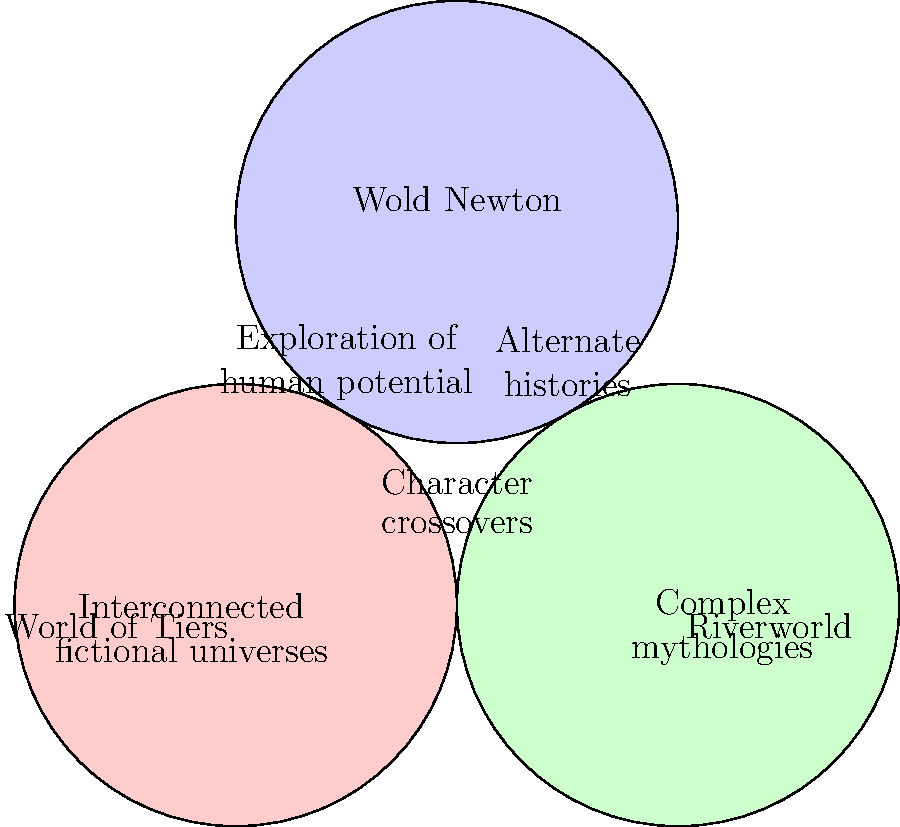Analyze the Venn diagram illustrating common themes across Philip José Farmer's major series (World of Tiers, Riverworld, and Wold Newton). Which theme is shared by all three series, representing Farmer's overarching interest throughout his literary career? To answer this question, let's examine the Venn diagram step-by-step:

1. The diagram shows three overlapping circles, each representing one of Farmer's major series:
   - World of Tiers
   - Riverworld
   - Wold Newton

2. Each circle contains themes specific to that series, while overlapping areas represent shared themes.

3. The themes specific to each series are:
   - World of Tiers: "Exploration of human potential"
   - Riverworld: "Complex mythologies"
   - Wold Newton: "Alternate histories"

4. Themes shared by two series:
   - World of Tiers and Riverworld: "Interconnected fictional universes"
   - Riverworld and Wold Newton: "Character crossovers"

5. The central area where all three circles overlap represents a theme common to all three series.

6. The theme in this central area is "Character crossovers," indicating that this is a recurring element in all three of Farmer's major series.

7. This shared theme reflects Farmer's consistent interest in interconnecting different fictional universes and characters throughout his literary career.
Answer: Character crossovers 